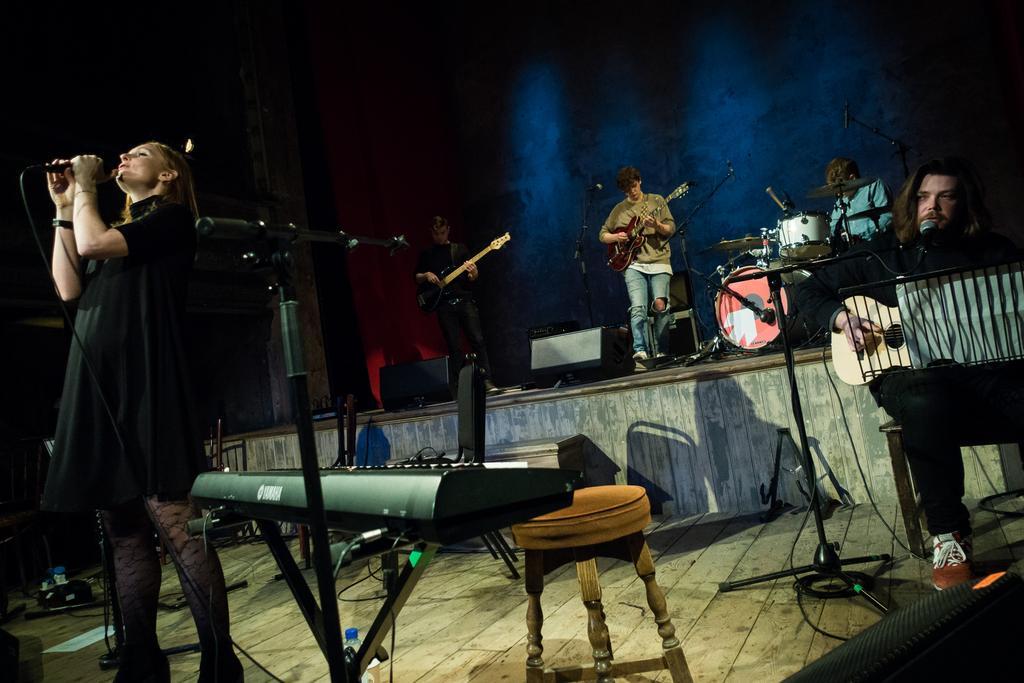Describe this image in one or two sentences. In this image there are group of people who are standing on the left side there is one woman who is standing and she is holding a mike. On the right side there is one man who is sitting and he is holding a guitar in front of him there is one board on that board there is one paper. In the background there are three persons. On the left side there is one man who is standing and he is holding a guitar. In the middle there is one man who is standing and he is also holding a guitar. On the left side there is one man who is sitting and he is drumming. On the background there is wall and in the foreground there is stool keyboard and chairs are there on the floor. 